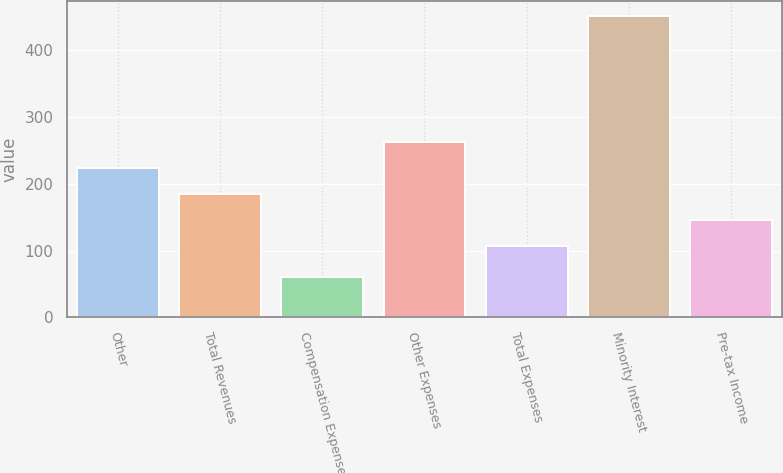Convert chart to OTSL. <chart><loc_0><loc_0><loc_500><loc_500><bar_chart><fcel>Other<fcel>Total Revenues<fcel>Compensation Expense<fcel>Other Expenses<fcel>Total Expenses<fcel>Minority Interest<fcel>Pre-tax Income<nl><fcel>222.7<fcel>183.8<fcel>61<fcel>261.6<fcel>106<fcel>450<fcel>144.9<nl></chart> 